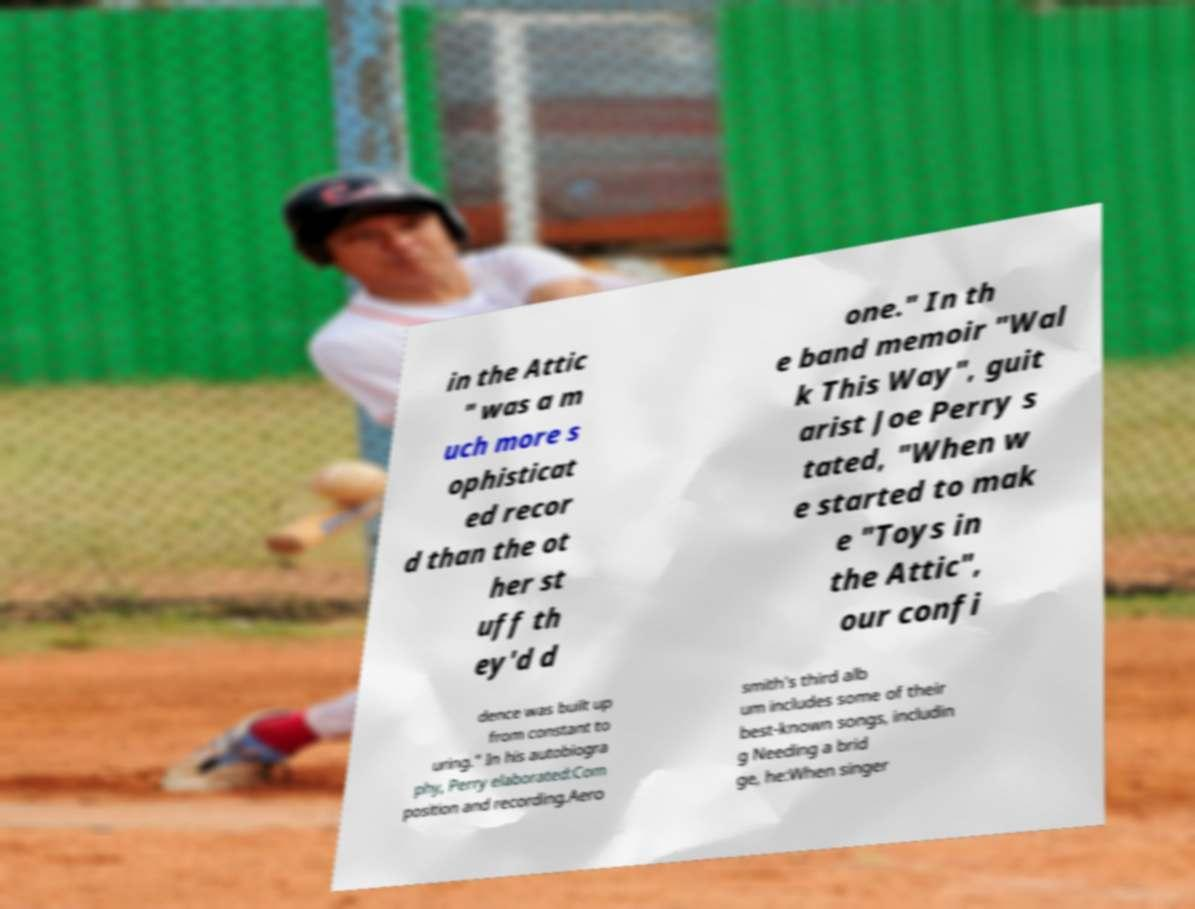For documentation purposes, I need the text within this image transcribed. Could you provide that? in the Attic " was a m uch more s ophisticat ed recor d than the ot her st uff th ey'd d one." In th e band memoir "Wal k This Way", guit arist Joe Perry s tated, "When w e started to mak e "Toys in the Attic", our confi dence was built up from constant to uring." In his autobiogra phy, Perry elaborated:Com position and recording.Aero smith's third alb um includes some of their best-known songs, includin g Needing a brid ge, he:When singer 